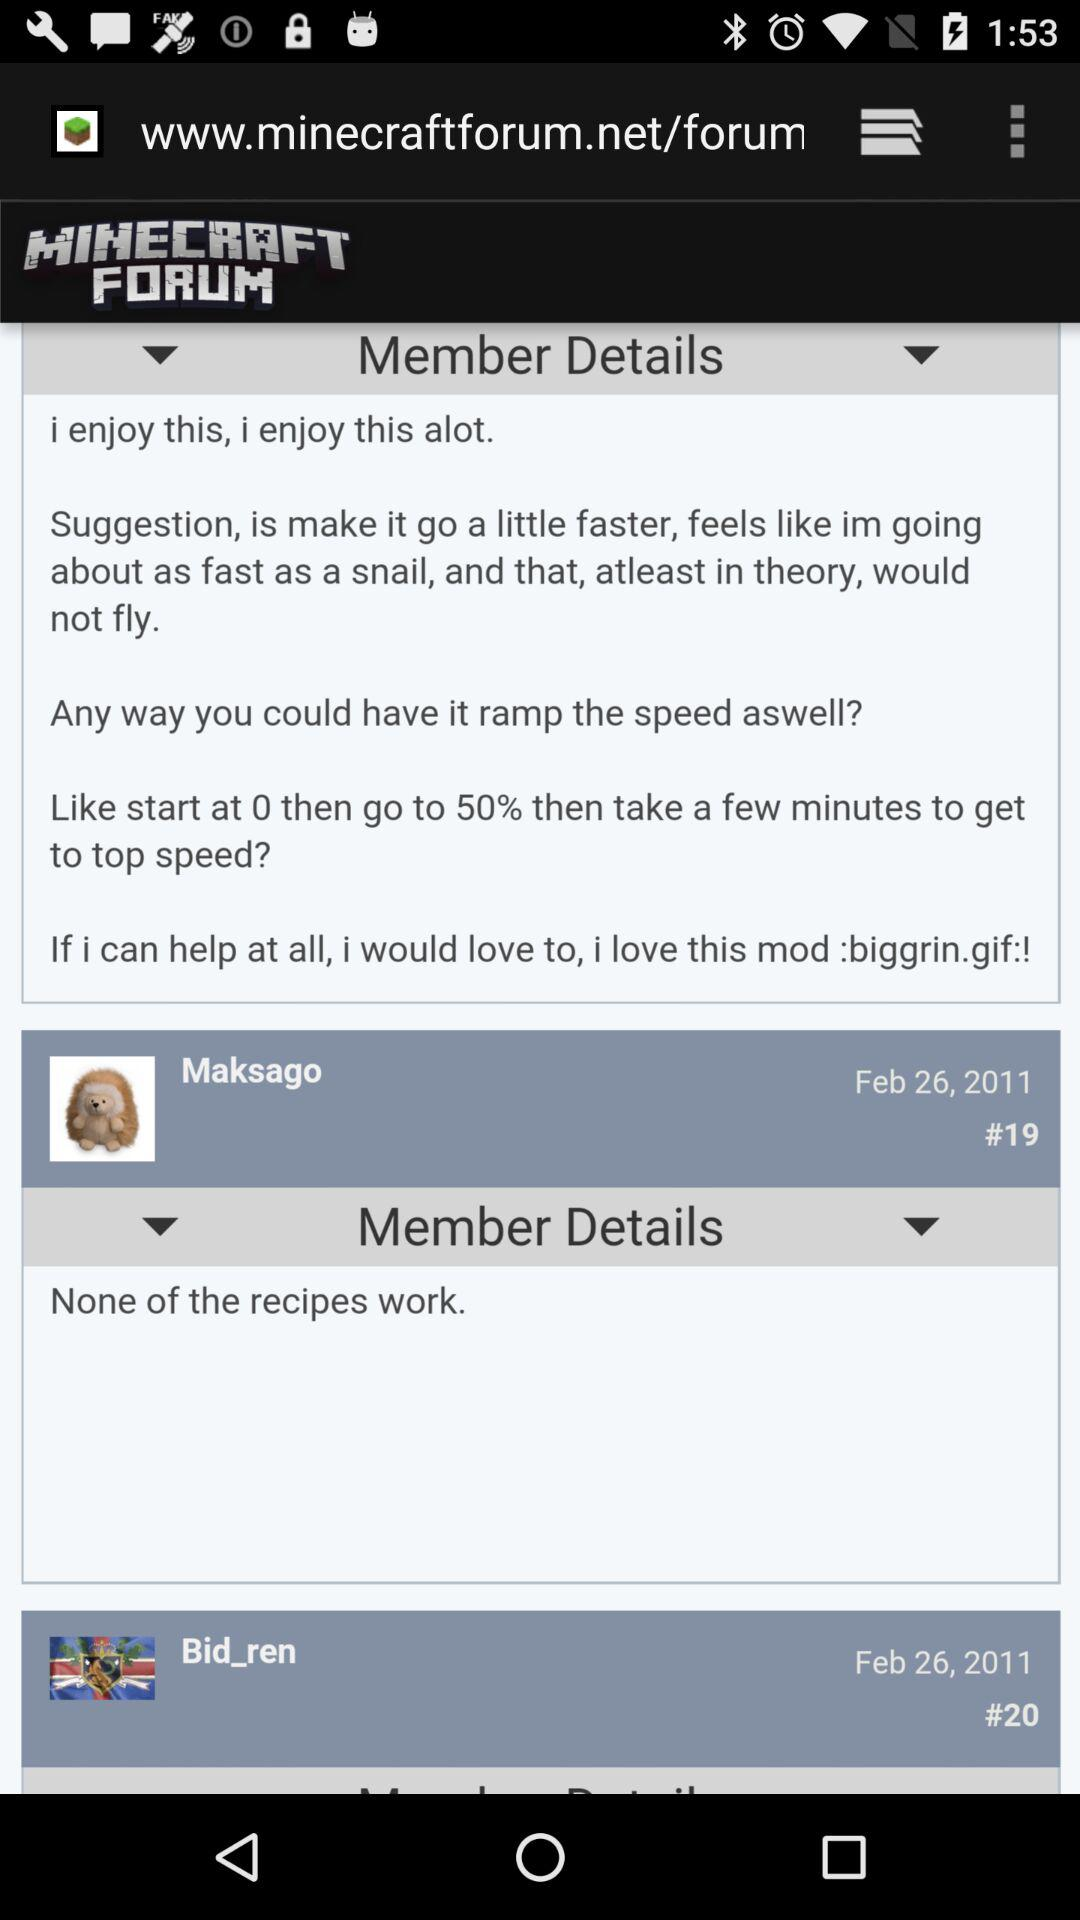How many posts have a member details link?
Answer the question using a single word or phrase. 2 